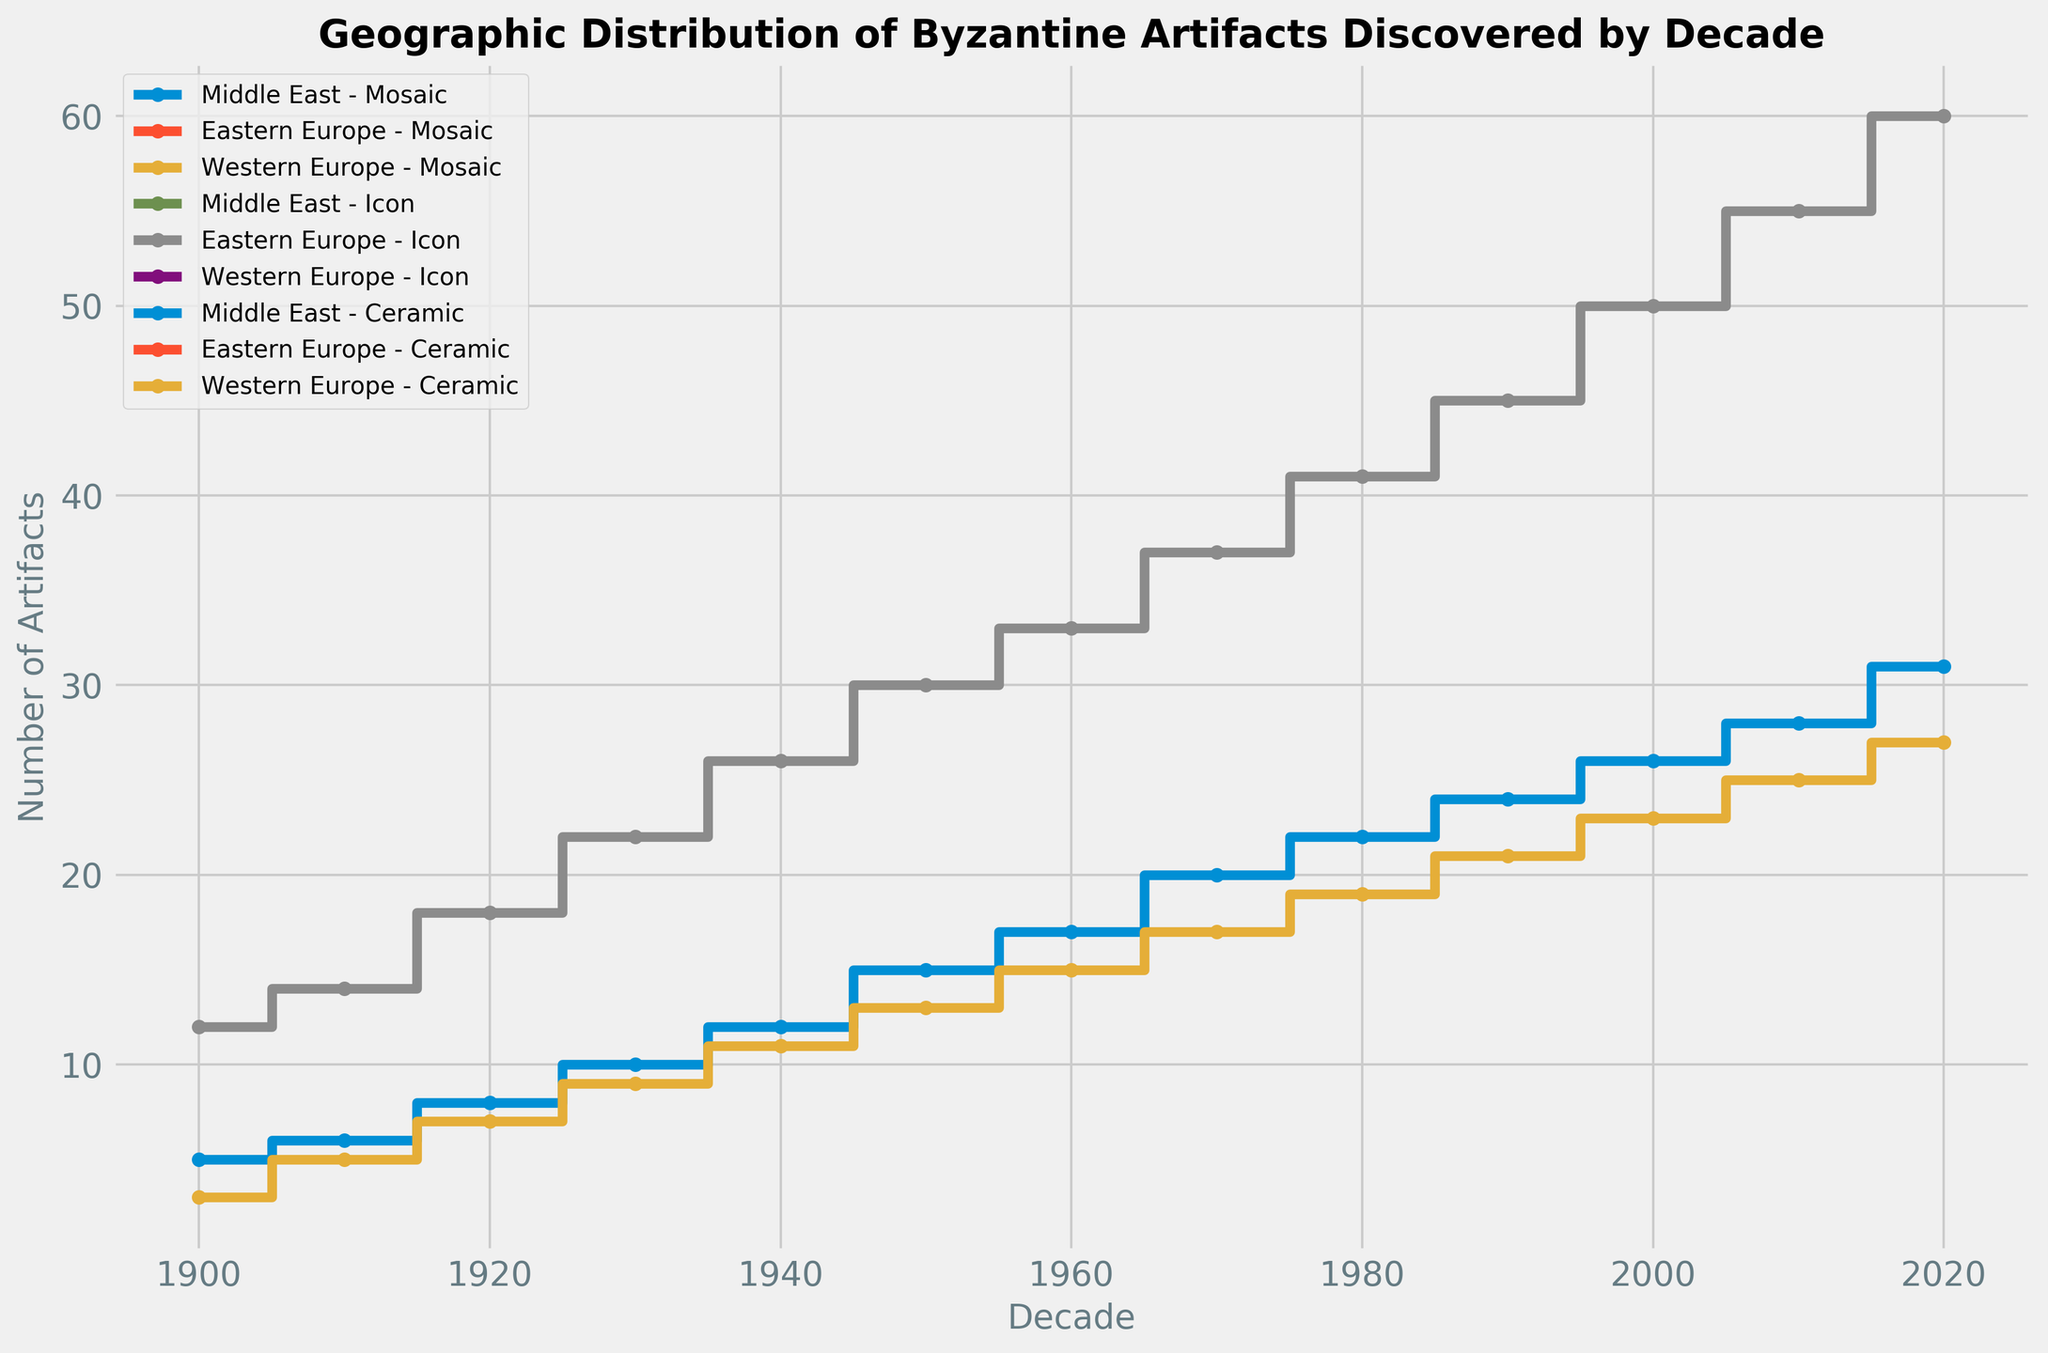Which region and artifact type combination showed the highest number of artifacts discovered in the 1920s? Identify the count values for each combination in the 1920 decade in the plot. The combination of Eastern Europe and Icon has the highest count of 18 artifacts.
Answer: Eastern Europe - Icon How did the count of Middle Eastern Mosaic artifacts change from 1900 to 2020? Observe the step plot line for Middle Eastern Mosaic artifacts. It starts at 5 artifacts in 1900 and ends at 31 artifacts in 2020, showing a gradual increase over each decade.
Answer: Increased from 5 to 31 Which artifact type showed the most consistent increase in artifact discoveries across all regions? Look for the artifact type with consistently increasing step lines across different regions. Icon artifacts in Eastern Europe steadily increase from 12 in 1900 to 60 in 2020.
Answer: Icon Compare the total number of artifacts discovered in Western Europe to those in the Middle East in the 2010s. Add the counts for Western European Ceramics (25) and Middle Eastern Mosaics (28) for the 2010 decade.
Answer: 25 vs 28 What is the average number of artifacts discovered per decade for Eastern European Icons? Sum the counts for Eastern European Icons for each decade from 1900 to 2020 and divide by the number of decades (13). Sum: 12 + 14 + 18 + 22 + 26 + 30 + 33 + 37 + 41 + 45 + 50 + 55 + 60 = 443. Average: 443 / 13 = 34.08
Answer: 34.08 Which artifact type in Western Europe experienced the largest increase between any two consecutive decades? Identify and compare increments between consecutive decades for Western European Ceramics. The largest increase is from 2000 (23) to 2010 (25), an increase of 2.
Answer: Ceramic (2000 to 2010) During which decade did Eastern European Icons first surpass a count of 20 artifacts? Check the step plot for Eastern European Icons to find the first decade where the count goes beyond 20. This happens in the 1930s.
Answer: 1930s Among all artifact types and regions, which combination experienced the largest single-decade increase in discovered artifacts? Identify the region and artifact type with the steepest increase between two consecutive points. The count for Eastern European Icons increased by 5 from 2010 (55) to 2020 (60).
Answer: Eastern Europe - Icon (2010 to 2020) What is the trend for Western European Ceramic artifacts from 1900 to 2020? Track the step plot line for Western European Ceramic artifacts from 1900 (3) to 2020 (27), noting any increases or fluctuations. It shows a steady increase.
Answer: Steady increase Visually, which region’s artifacts appear to have the smallest count differences between decades? Identify the step plot line with the smallest vertical changes per decade. This appears to be the Middle Eastern Mosaics, which show smaller and more consistent step increases.
Answer: Middle East 